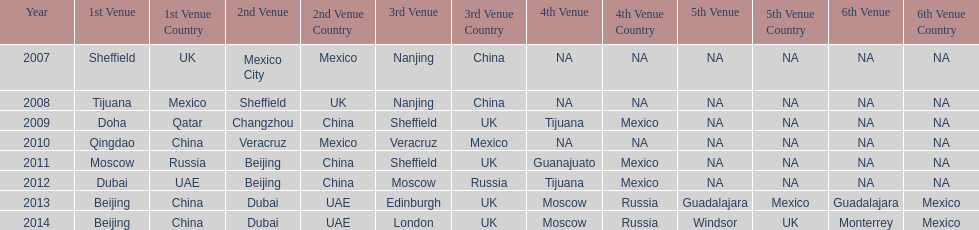Which year had more venues, 2007 or 2012? 2012. 